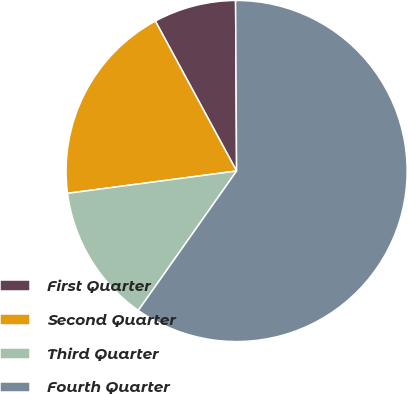<chart> <loc_0><loc_0><loc_500><loc_500><pie_chart><fcel>First Quarter<fcel>Second Quarter<fcel>Third Quarter<fcel>Fourth Quarter<nl><fcel>7.81%<fcel>19.19%<fcel>13.14%<fcel>59.87%<nl></chart> 